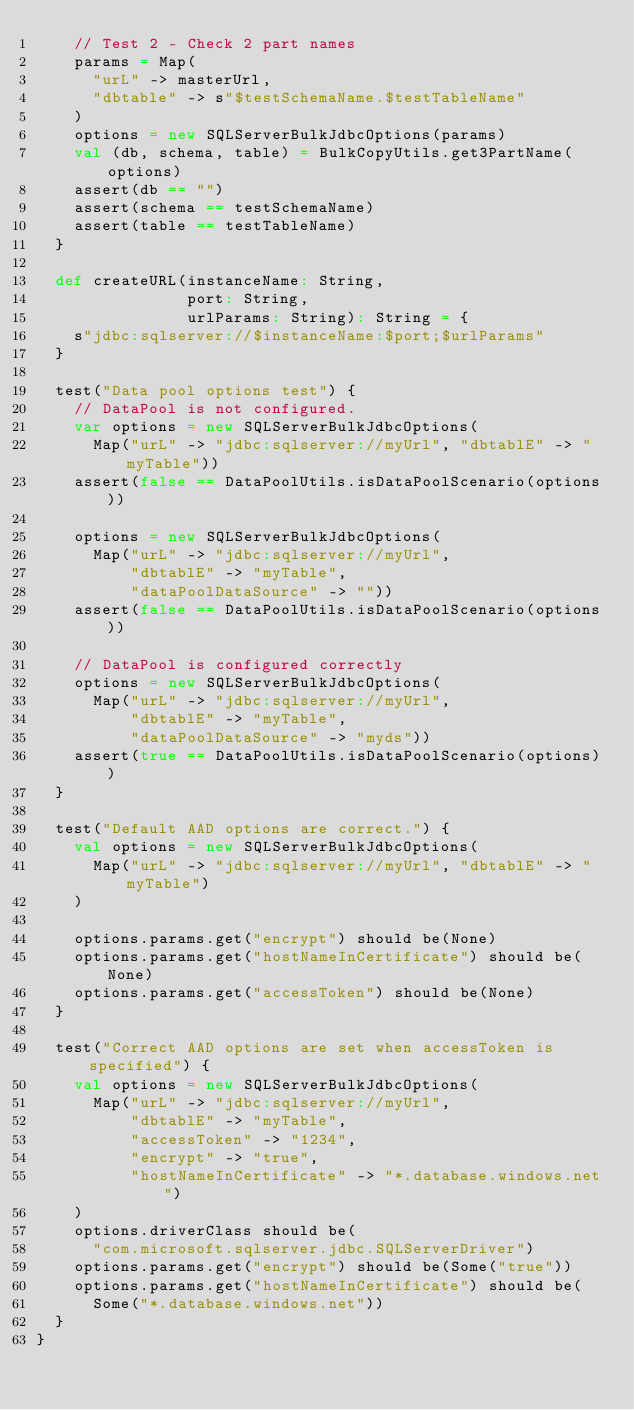<code> <loc_0><loc_0><loc_500><loc_500><_Scala_>    // Test 2 - Check 2 part names
    params = Map(
      "urL" -> masterUrl,
      "dbtable" -> s"$testSchemaName.$testTableName"
    )
    options = new SQLServerBulkJdbcOptions(params)
    val (db, schema, table) = BulkCopyUtils.get3PartName(options)
    assert(db == "")
    assert(schema == testSchemaName)
    assert(table == testTableName)
  }

  def createURL(instanceName: String,
                port: String,
                urlParams: String): String = {
    s"jdbc:sqlserver://$instanceName:$port;$urlParams"
  }

  test("Data pool options test") {
    // DataPool is not configured.
    var options = new SQLServerBulkJdbcOptions(
      Map("urL" -> "jdbc:sqlserver://myUrl", "dbtablE" -> "myTable"))
    assert(false == DataPoolUtils.isDataPoolScenario(options))

    options = new SQLServerBulkJdbcOptions(
      Map("urL" -> "jdbc:sqlserver://myUrl",
          "dbtablE" -> "myTable",
          "dataPoolDataSource" -> ""))
    assert(false == DataPoolUtils.isDataPoolScenario(options))

    // DataPool is configured correctly
    options = new SQLServerBulkJdbcOptions(
      Map("urL" -> "jdbc:sqlserver://myUrl",
          "dbtablE" -> "myTable",
          "dataPoolDataSource" -> "myds"))
    assert(true == DataPoolUtils.isDataPoolScenario(options))
  }

  test("Default AAD options are correct.") {
    val options = new SQLServerBulkJdbcOptions(
      Map("urL" -> "jdbc:sqlserver://myUrl", "dbtablE" -> "myTable")
    )

    options.params.get("encrypt") should be(None)
    options.params.get("hostNameInCertificate") should be(None)
    options.params.get("accessToken") should be(None)
  }

  test("Correct AAD options are set when accessToken is specified") {
    val options = new SQLServerBulkJdbcOptions(
      Map("urL" -> "jdbc:sqlserver://myUrl",
          "dbtablE" -> "myTable",
          "accessToken" -> "1234",
          "encrypt" -> "true",
          "hostNameInCertificate" -> "*.database.windows.net")
    )
    options.driverClass should be(
      "com.microsoft.sqlserver.jdbc.SQLServerDriver")
    options.params.get("encrypt") should be(Some("true"))
    options.params.get("hostNameInCertificate") should be(
      Some("*.database.windows.net"))
  }
}
</code> 